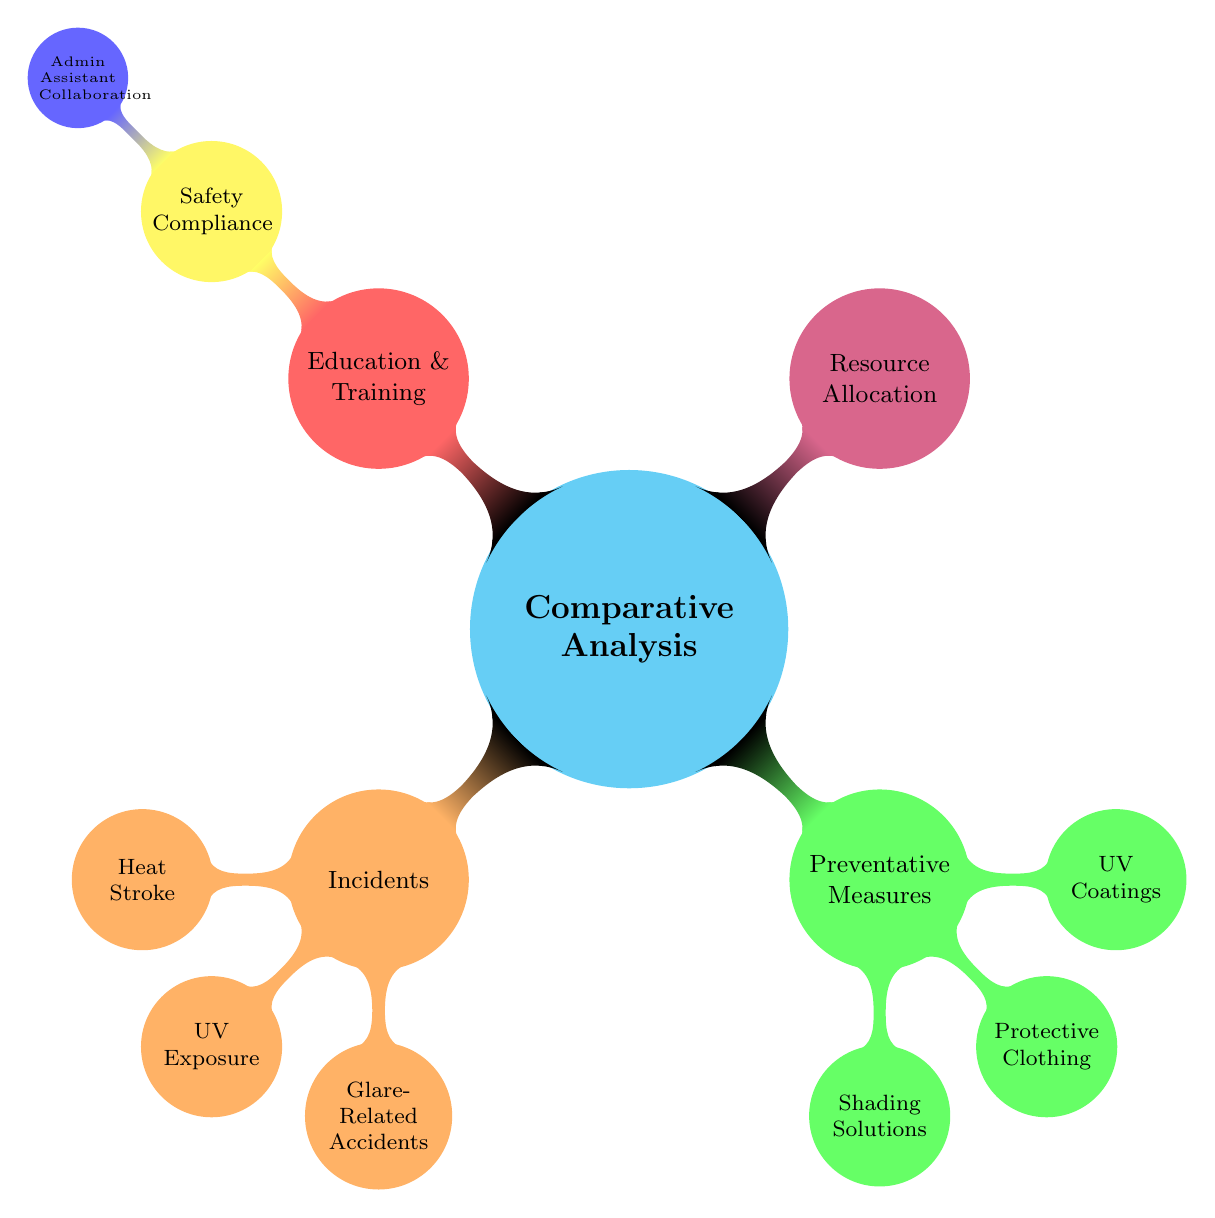What are the main categories of the comparative analysis? The diagram shows three main categories: Incidents, Preventative Measures, and Resource Allocation. These categories are the top-level nodes in the mindmap.
Answer: Incidents, Preventative Measures, Resource Allocation How many different incidents are listed in the diagram? The diagram outlines three specific incidents: Heat Stroke, UV Exposure, and Glare-Related Accidents, which are child nodes under the Incidents category.
Answer: 3 Which preventative measure addresses UV exposure? The diagram specifies UV Coatings as a preventative measure that directly addresses UV exposure under the Preventative Measures category.
Answer: UV Coatings What is linked to Safety Compliance in the diagram? Safety Compliance is connected to Education & Training, which indicates a hierarchy where Education & Training encompasses Safety Compliance.
Answer: Education & Training Which category contains the node for Admin Assistant Collaboration? The node for Admin Assistant Collaboration is found under the Education & Training category, which is a child node of the red section in the diagram.
Answer: Education & Training How many child nodes are associated with the Incidents category? Under the Incidents category, there are three child nodes listed: Heat Stroke, UV Exposure, and Glare-Related Accidents, indicating the specifics of incidents identified.
Answer: 3 Which color represents the Preventative Measures in the diagram? The Preventative Measures category is represented by the green color in the diagram, indicating its distinct section visually.
Answer: Green What relationship exists between Resource Allocation and the other categories? Resource Allocation stands alone as a category without any children or direct connections to other categories, suggesting it is a separate concept in this analysis.
Answer: None Which category would likely focus on employee education regarding safety protocols? The Education & Training category would focus on employee education regarding safety protocols, as it encompasses training and compliance efforts within the diagram.
Answer: Education & Training 